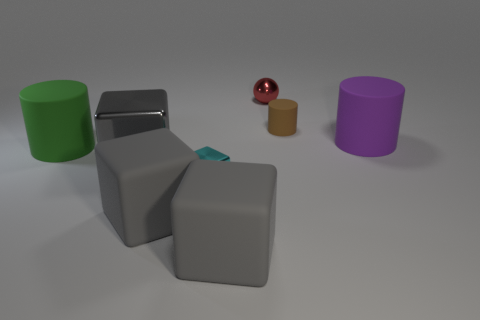Subtract all green cylinders. How many gray blocks are left? 3 Subtract 1 blocks. How many blocks are left? 3 Add 2 small things. How many objects exist? 10 Subtract all cylinders. How many objects are left? 5 Add 4 green rubber objects. How many green rubber objects exist? 5 Subtract 0 blue balls. How many objects are left? 8 Subtract all large gray blocks. Subtract all purple things. How many objects are left? 4 Add 1 blocks. How many blocks are left? 5 